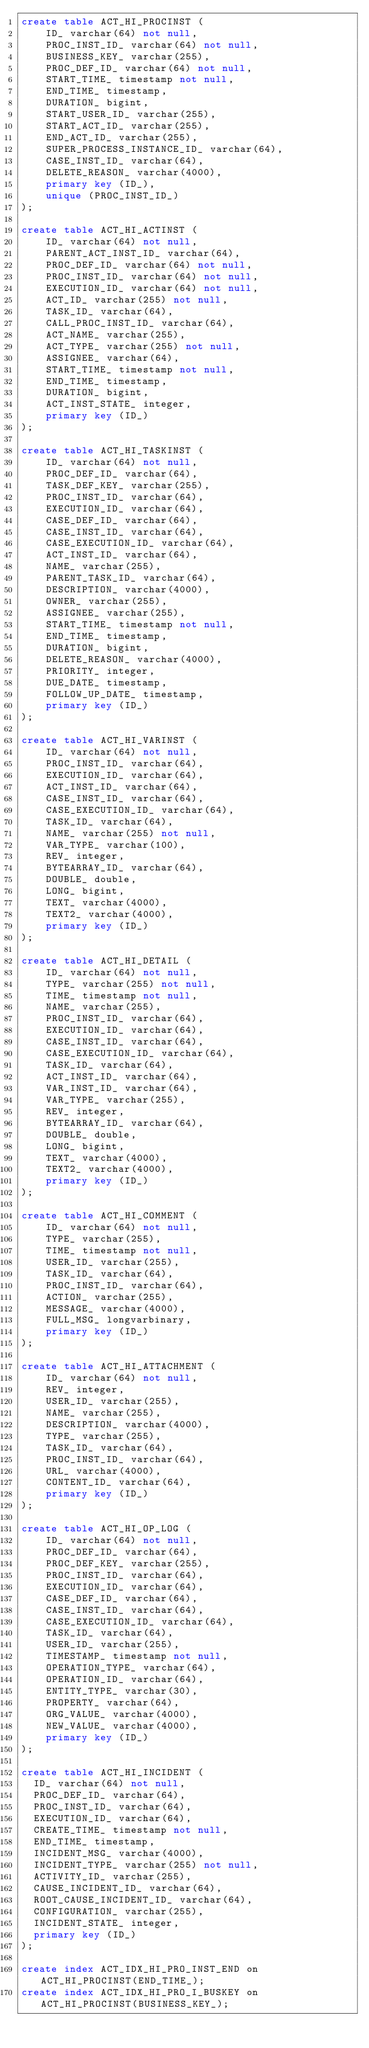<code> <loc_0><loc_0><loc_500><loc_500><_SQL_>create table ACT_HI_PROCINST (
    ID_ varchar(64) not null,
    PROC_INST_ID_ varchar(64) not null,
    BUSINESS_KEY_ varchar(255),
    PROC_DEF_ID_ varchar(64) not null,
    START_TIME_ timestamp not null,
    END_TIME_ timestamp,
    DURATION_ bigint,
    START_USER_ID_ varchar(255),
    START_ACT_ID_ varchar(255),
    END_ACT_ID_ varchar(255),
    SUPER_PROCESS_INSTANCE_ID_ varchar(64),
    CASE_INST_ID_ varchar(64),
    DELETE_REASON_ varchar(4000),
    primary key (ID_),
    unique (PROC_INST_ID_)
);

create table ACT_HI_ACTINST (
    ID_ varchar(64) not null,
    PARENT_ACT_INST_ID_ varchar(64),
    PROC_DEF_ID_ varchar(64) not null,
    PROC_INST_ID_ varchar(64) not null,
    EXECUTION_ID_ varchar(64) not null,
    ACT_ID_ varchar(255) not null,
    TASK_ID_ varchar(64),
    CALL_PROC_INST_ID_ varchar(64),
    ACT_NAME_ varchar(255),
    ACT_TYPE_ varchar(255) not null,
    ASSIGNEE_ varchar(64),
    START_TIME_ timestamp not null,
    END_TIME_ timestamp,
    DURATION_ bigint,
    ACT_INST_STATE_ integer,
    primary key (ID_)
);

create table ACT_HI_TASKINST (
    ID_ varchar(64) not null,
    PROC_DEF_ID_ varchar(64),
    TASK_DEF_KEY_ varchar(255),
    PROC_INST_ID_ varchar(64),
    EXECUTION_ID_ varchar(64),
    CASE_DEF_ID_ varchar(64),
    CASE_INST_ID_ varchar(64),
    CASE_EXECUTION_ID_ varchar(64),
    ACT_INST_ID_ varchar(64),
    NAME_ varchar(255),
    PARENT_TASK_ID_ varchar(64),
    DESCRIPTION_ varchar(4000),
    OWNER_ varchar(255),
    ASSIGNEE_ varchar(255),
    START_TIME_ timestamp not null,
    END_TIME_ timestamp,
    DURATION_ bigint,
    DELETE_REASON_ varchar(4000),
    PRIORITY_ integer,
    DUE_DATE_ timestamp,
    FOLLOW_UP_DATE_ timestamp,
    primary key (ID_)
);

create table ACT_HI_VARINST (
    ID_ varchar(64) not null,
    PROC_INST_ID_ varchar(64),
    EXECUTION_ID_ varchar(64),
    ACT_INST_ID_ varchar(64),
    CASE_INST_ID_ varchar(64),
    CASE_EXECUTION_ID_ varchar(64),
    TASK_ID_ varchar(64),
    NAME_ varchar(255) not null,
    VAR_TYPE_ varchar(100),
    REV_ integer,
    BYTEARRAY_ID_ varchar(64),
    DOUBLE_ double,
    LONG_ bigint,
    TEXT_ varchar(4000),
    TEXT2_ varchar(4000),
    primary key (ID_)
);

create table ACT_HI_DETAIL (
    ID_ varchar(64) not null,
    TYPE_ varchar(255) not null,
    TIME_ timestamp not null,
    NAME_ varchar(255),
    PROC_INST_ID_ varchar(64),
    EXECUTION_ID_ varchar(64),
    CASE_INST_ID_ varchar(64),
    CASE_EXECUTION_ID_ varchar(64),
    TASK_ID_ varchar(64),
    ACT_INST_ID_ varchar(64),
    VAR_INST_ID_ varchar(64),
    VAR_TYPE_ varchar(255),
    REV_ integer,
    BYTEARRAY_ID_ varchar(64),
    DOUBLE_ double,
    LONG_ bigint,
    TEXT_ varchar(4000),
    TEXT2_ varchar(4000),
    primary key (ID_)
);

create table ACT_HI_COMMENT (
    ID_ varchar(64) not null,
    TYPE_ varchar(255),
    TIME_ timestamp not null,
    USER_ID_ varchar(255),
    TASK_ID_ varchar(64),
    PROC_INST_ID_ varchar(64),
    ACTION_ varchar(255),
    MESSAGE_ varchar(4000),
    FULL_MSG_ longvarbinary,
    primary key (ID_)
);

create table ACT_HI_ATTACHMENT (
    ID_ varchar(64) not null,
    REV_ integer,
    USER_ID_ varchar(255),
    NAME_ varchar(255),
    DESCRIPTION_ varchar(4000),
    TYPE_ varchar(255),
    TASK_ID_ varchar(64),
    PROC_INST_ID_ varchar(64),
    URL_ varchar(4000),
    CONTENT_ID_ varchar(64),
    primary key (ID_)
);

create table ACT_HI_OP_LOG (
    ID_ varchar(64) not null,
    PROC_DEF_ID_ varchar(64),
    PROC_DEF_KEY_ varchar(255),
    PROC_INST_ID_ varchar(64),
    EXECUTION_ID_ varchar(64),
    CASE_DEF_ID_ varchar(64),
    CASE_INST_ID_ varchar(64),
    CASE_EXECUTION_ID_ varchar(64),
    TASK_ID_ varchar(64),
    USER_ID_ varchar(255),
    TIMESTAMP_ timestamp not null,
    OPERATION_TYPE_ varchar(64),
    OPERATION_ID_ varchar(64),
    ENTITY_TYPE_ varchar(30),
    PROPERTY_ varchar(64),
    ORG_VALUE_ varchar(4000),
    NEW_VALUE_ varchar(4000),
    primary key (ID_)
);

create table ACT_HI_INCIDENT (
  ID_ varchar(64) not null,
  PROC_DEF_ID_ varchar(64),
  PROC_INST_ID_ varchar(64),
  EXECUTION_ID_ varchar(64),
  CREATE_TIME_ timestamp not null,
  END_TIME_ timestamp,
  INCIDENT_MSG_ varchar(4000),
  INCIDENT_TYPE_ varchar(255) not null,
  ACTIVITY_ID_ varchar(255),
  CAUSE_INCIDENT_ID_ varchar(64),
  ROOT_CAUSE_INCIDENT_ID_ varchar(64),
  CONFIGURATION_ varchar(255),
  INCIDENT_STATE_ integer,
  primary key (ID_)
);

create index ACT_IDX_HI_PRO_INST_END on ACT_HI_PROCINST(END_TIME_);
create index ACT_IDX_HI_PRO_I_BUSKEY on ACT_HI_PROCINST(BUSINESS_KEY_);</code> 